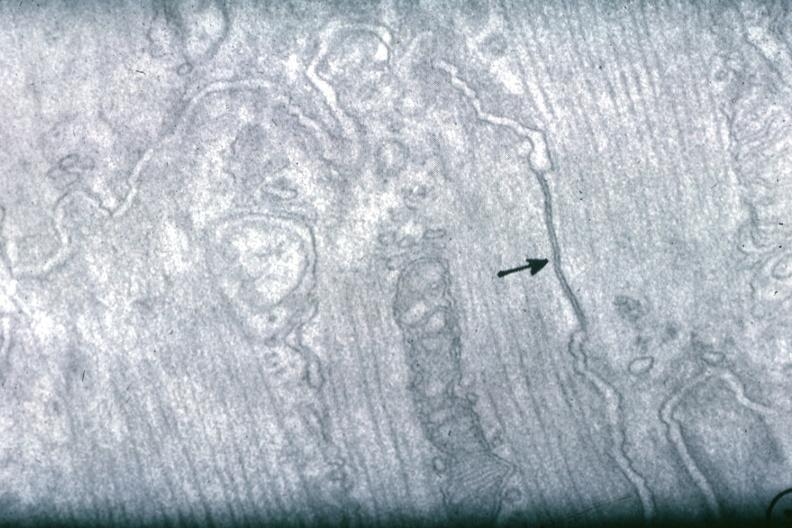s metastatic carcinoma present?
Answer the question using a single word or phrase. No 